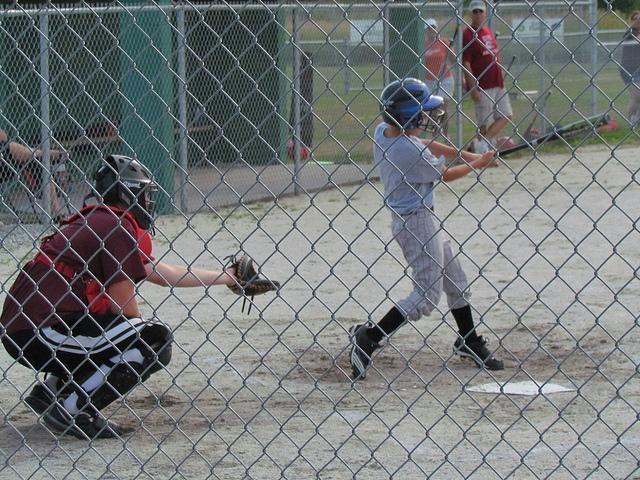How many people are there?
Give a very brief answer. 5. 